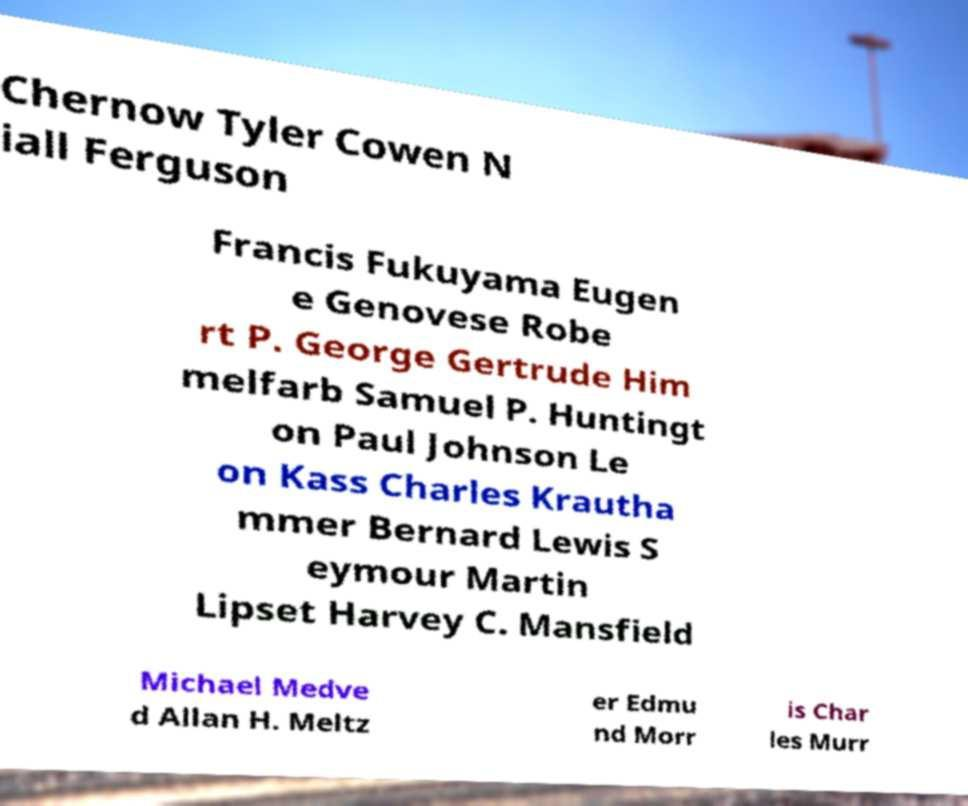For documentation purposes, I need the text within this image transcribed. Could you provide that? Chernow Tyler Cowen N iall Ferguson Francis Fukuyama Eugen e Genovese Robe rt P. George Gertrude Him melfarb Samuel P. Huntingt on Paul Johnson Le on Kass Charles Krautha mmer Bernard Lewis S eymour Martin Lipset Harvey C. Mansfield Michael Medve d Allan H. Meltz er Edmu nd Morr is Char les Murr 